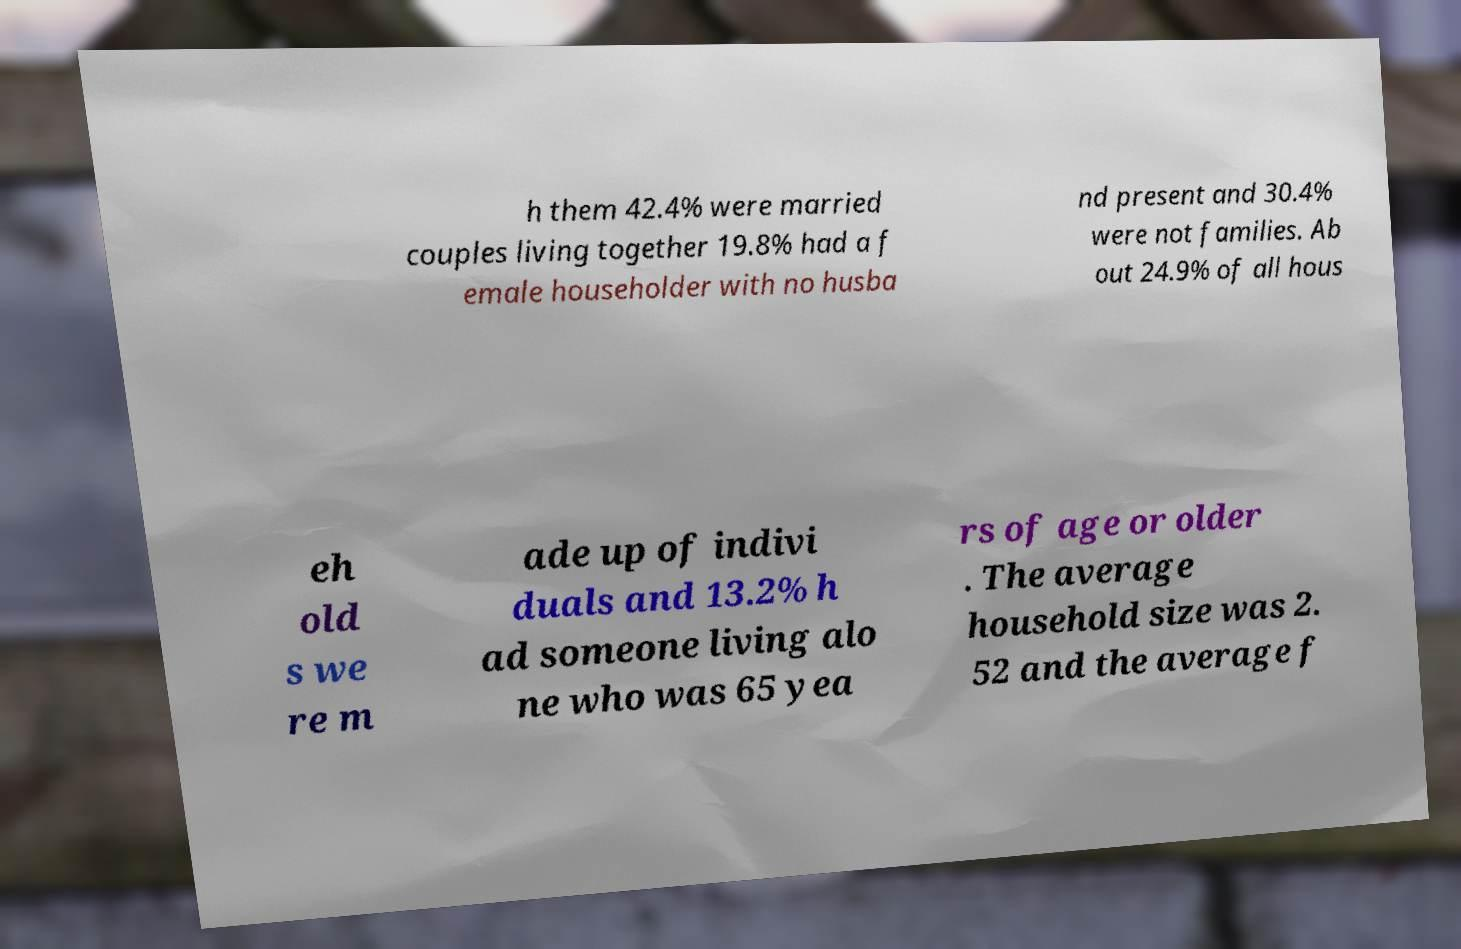For documentation purposes, I need the text within this image transcribed. Could you provide that? h them 42.4% were married couples living together 19.8% had a f emale householder with no husba nd present and 30.4% were not families. Ab out 24.9% of all hous eh old s we re m ade up of indivi duals and 13.2% h ad someone living alo ne who was 65 yea rs of age or older . The average household size was 2. 52 and the average f 